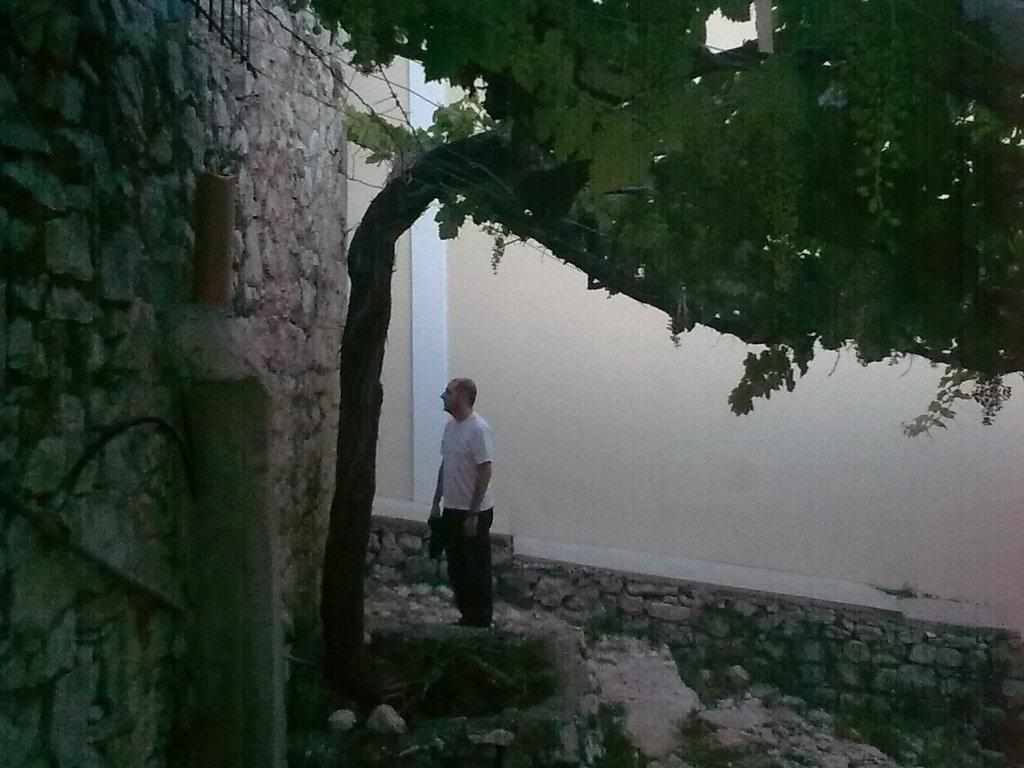Who is present in the image? There is a man in the image. What is on the left side of the man? There is a wall on the left side of the man. What is in front of the wall? There is a tree in front of the wall. What is behind the man? There is a wall behind the man. What time does the clock on the wall indicate in the image? There is no clock present in the image, so it is not possible to determine the time. 